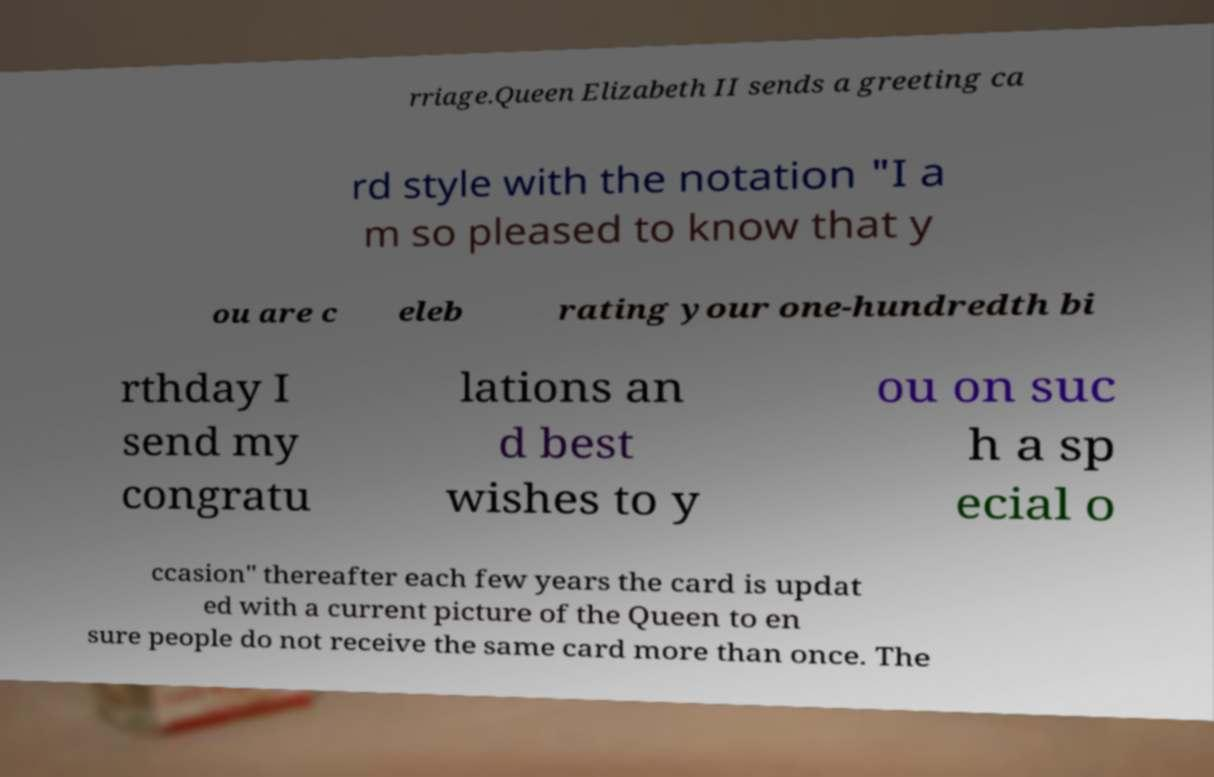Can you accurately transcribe the text from the provided image for me? rriage.Queen Elizabeth II sends a greeting ca rd style with the notation "I a m so pleased to know that y ou are c eleb rating your one-hundredth bi rthday I send my congratu lations an d best wishes to y ou on suc h a sp ecial o ccasion" thereafter each few years the card is updat ed with a current picture of the Queen to en sure people do not receive the same card more than once. The 